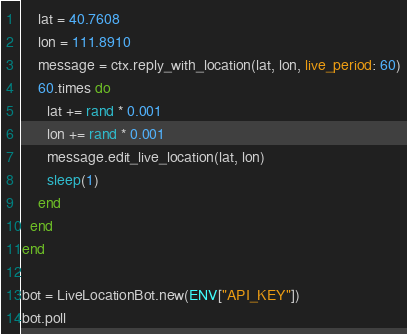<code> <loc_0><loc_0><loc_500><loc_500><_Crystal_>    lat = 40.7608
    lon = 111.8910
    message = ctx.reply_with_location(lat, lon, live_period: 60)
    60.times do
      lat += rand * 0.001
      lon += rand * 0.001
      message.edit_live_location(lat, lon)
      sleep(1)
    end
  end
end

bot = LiveLocationBot.new(ENV["API_KEY"])
bot.poll
</code> 